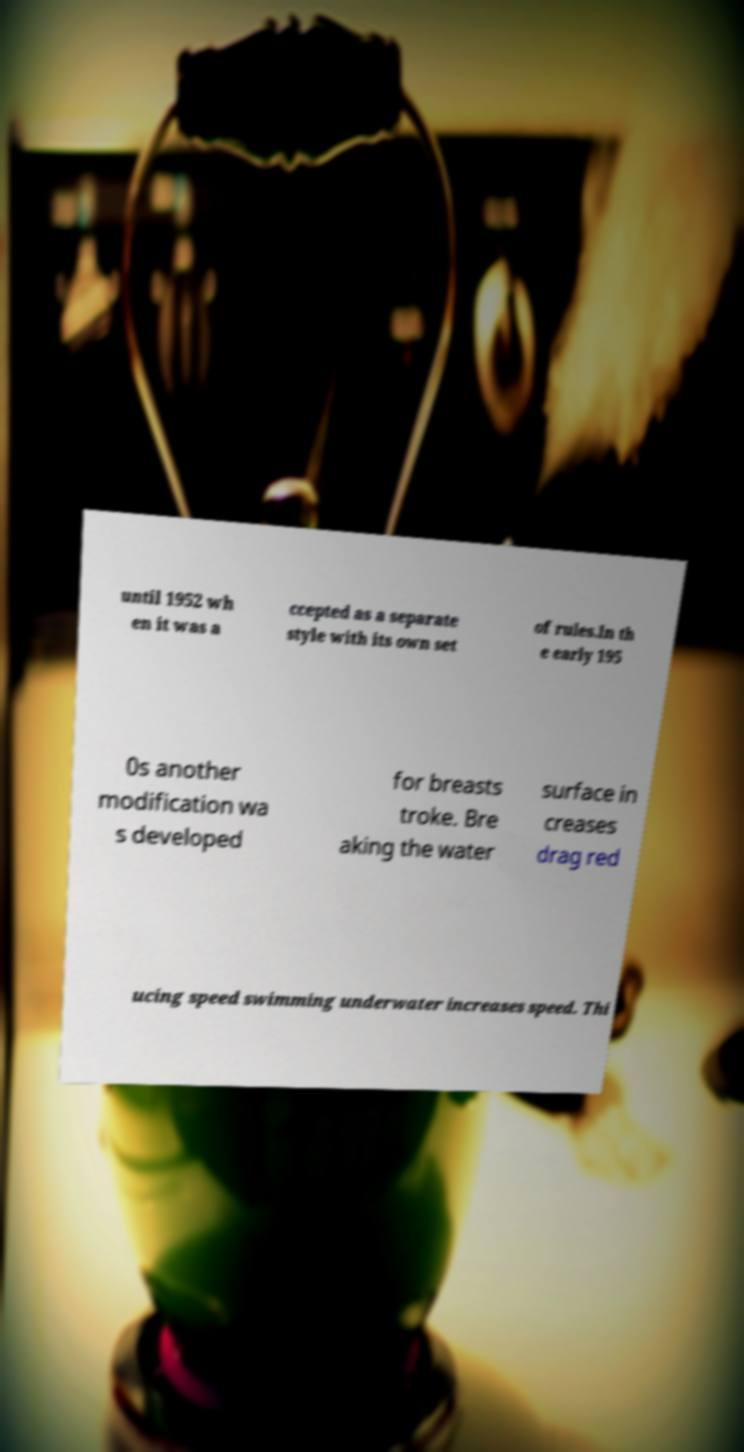Can you accurately transcribe the text from the provided image for me? until 1952 wh en it was a ccepted as a separate style with its own set of rules.In th e early 195 0s another modification wa s developed for breasts troke. Bre aking the water surface in creases drag red ucing speed swimming underwater increases speed. Thi 